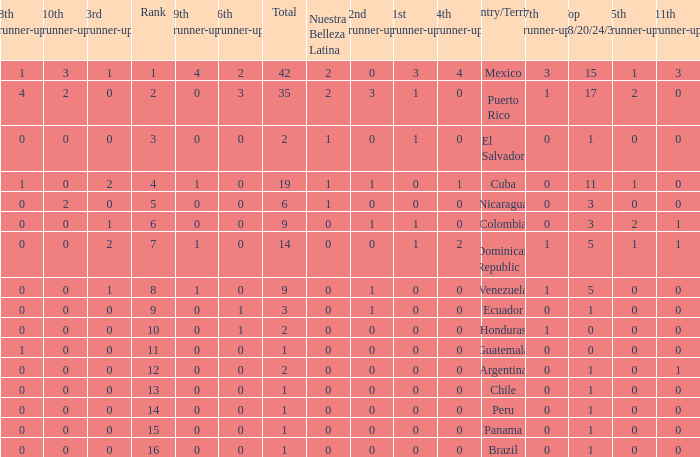What is the 7th runner-up of the country with a 10th runner-up greater than 0, a 9th runner-up greater than 0, and an 8th runner-up greater than 1? None. 